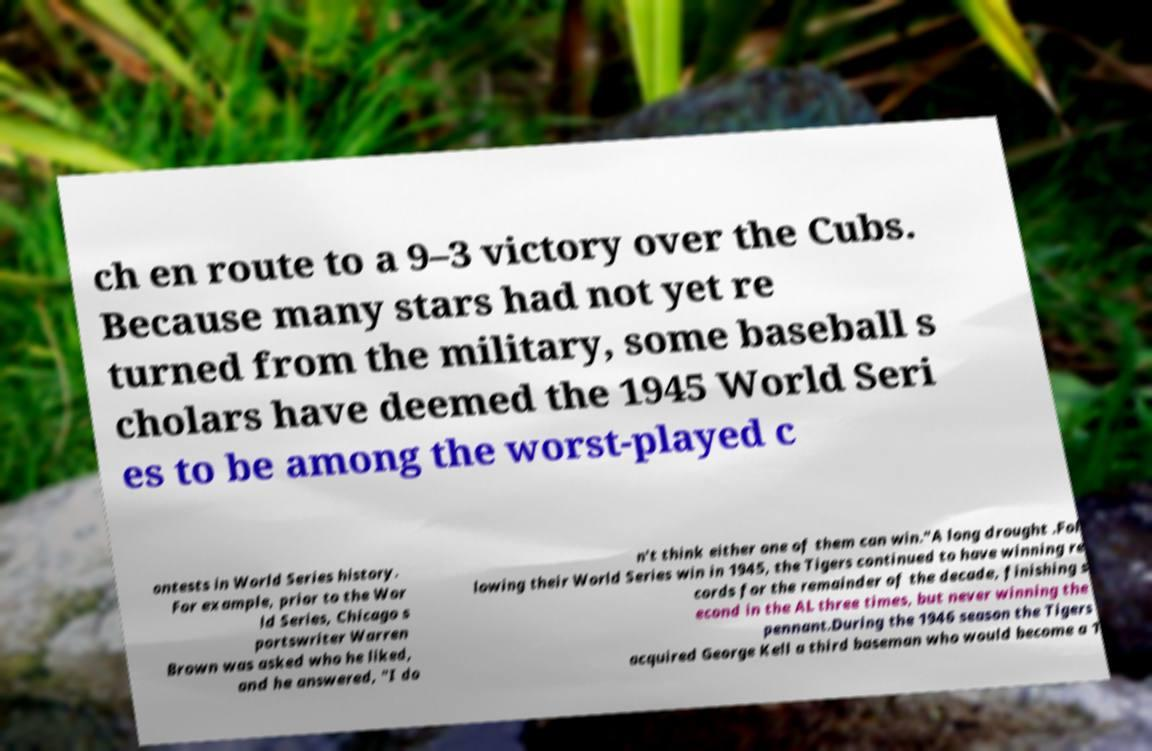Can you read and provide the text displayed in the image?This photo seems to have some interesting text. Can you extract and type it out for me? ch en route to a 9–3 victory over the Cubs. Because many stars had not yet re turned from the military, some baseball s cholars have deemed the 1945 World Seri es to be among the worst-played c ontests in World Series history. For example, prior to the Wor ld Series, Chicago s portswriter Warren Brown was asked who he liked, and he answered, "I do n't think either one of them can win."A long drought .Fol lowing their World Series win in 1945, the Tigers continued to have winning re cords for the remainder of the decade, finishing s econd in the AL three times, but never winning the pennant.During the 1946 season the Tigers acquired George Kell a third baseman who would become a 1 